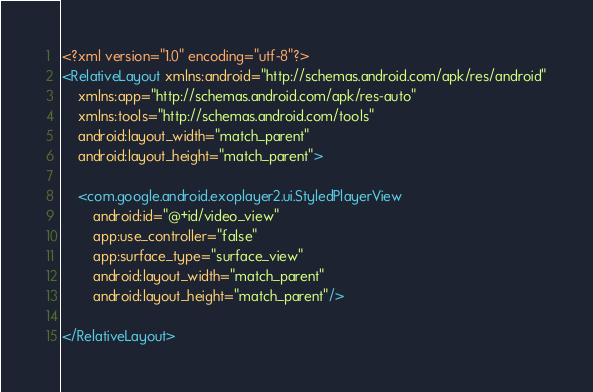<code> <loc_0><loc_0><loc_500><loc_500><_XML_><?xml version="1.0" encoding="utf-8"?>
<RelativeLayout xmlns:android="http://schemas.android.com/apk/res/android"
    xmlns:app="http://schemas.android.com/apk/res-auto"
    xmlns:tools="http://schemas.android.com/tools"
    android:layout_width="match_parent"
    android:layout_height="match_parent">

    <com.google.android.exoplayer2.ui.StyledPlayerView
        android:id="@+id/video_view"
        app:use_controller="false"
        app:surface_type="surface_view"
        android:layout_width="match_parent"
        android:layout_height="match_parent"/>

</RelativeLayout></code> 